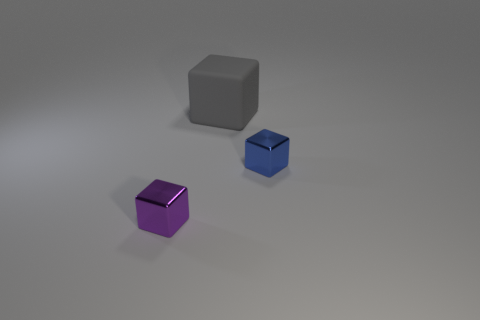Add 1 tiny blue objects. How many objects exist? 4 Add 3 purple objects. How many purple objects are left? 4 Add 1 large green rubber things. How many large green rubber things exist? 1 Subtract 1 gray cubes. How many objects are left? 2 Subtract all blue objects. Subtract all large gray rubber things. How many objects are left? 1 